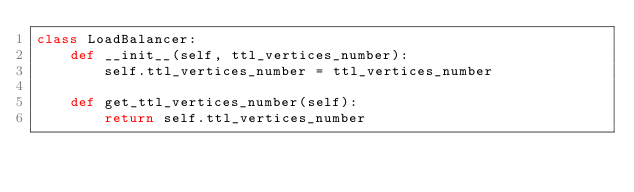Convert code to text. <code><loc_0><loc_0><loc_500><loc_500><_Python_>class LoadBalancer:
    def __init__(self, ttl_vertices_number):
        self.ttl_vertices_number = ttl_vertices_number

    def get_ttl_vertices_number(self):
        return self.ttl_vertices_number
</code> 